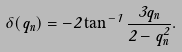<formula> <loc_0><loc_0><loc_500><loc_500>\delta ( q _ { n } ) = - 2 \tan ^ { - 1 } \frac { 3 q _ { n } } { 2 - q _ { n } ^ { 2 } } .</formula> 